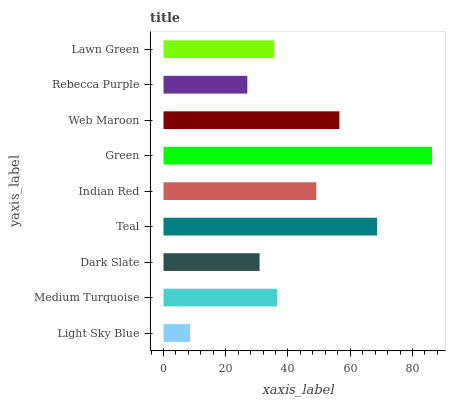Is Light Sky Blue the minimum?
Answer yes or no. Yes. Is Green the maximum?
Answer yes or no. Yes. Is Medium Turquoise the minimum?
Answer yes or no. No. Is Medium Turquoise the maximum?
Answer yes or no. No. Is Medium Turquoise greater than Light Sky Blue?
Answer yes or no. Yes. Is Light Sky Blue less than Medium Turquoise?
Answer yes or no. Yes. Is Light Sky Blue greater than Medium Turquoise?
Answer yes or no. No. Is Medium Turquoise less than Light Sky Blue?
Answer yes or no. No. Is Medium Turquoise the high median?
Answer yes or no. Yes. Is Medium Turquoise the low median?
Answer yes or no. Yes. Is Teal the high median?
Answer yes or no. No. Is Web Maroon the low median?
Answer yes or no. No. 